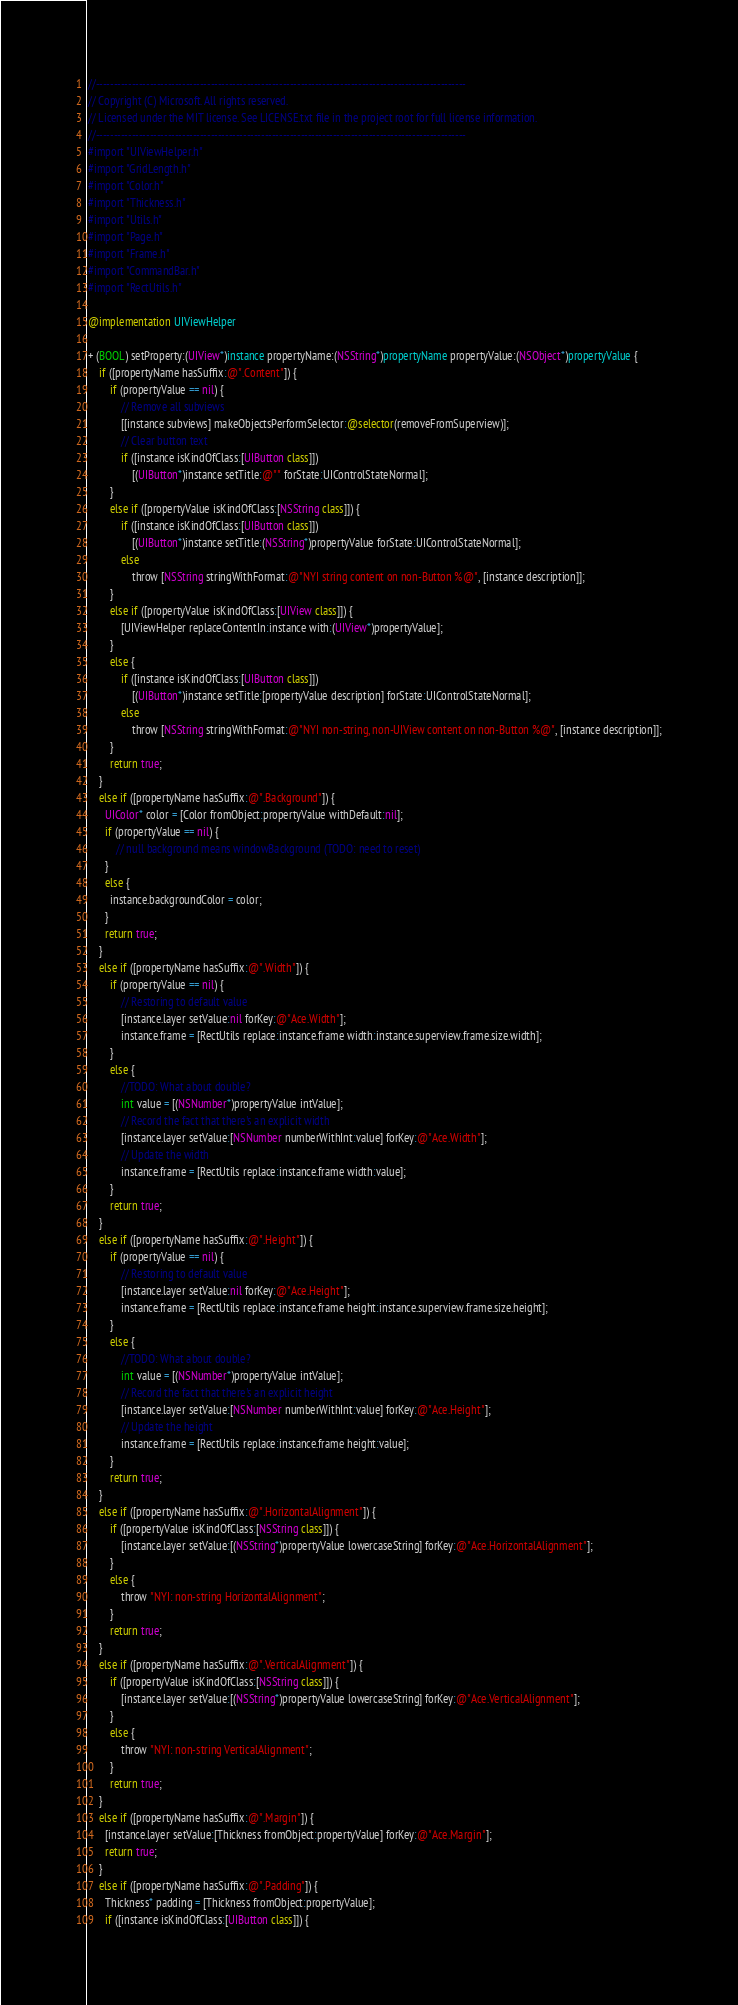Convert code to text. <code><loc_0><loc_0><loc_500><loc_500><_ObjectiveC_>//-------------------------------------------------------------------------------------------------------
// Copyright (C) Microsoft. All rights reserved.
// Licensed under the MIT license. See LICENSE.txt file in the project root for full license information.
//-------------------------------------------------------------------------------------------------------
#import "UIViewHelper.h"
#import "GridLength.h"
#import "Color.h"
#import "Thickness.h"
#import "Utils.h"
#import "Page.h"
#import "Frame.h"
#import "CommandBar.h"
#import "RectUtils.h"

@implementation UIViewHelper

+ (BOOL) setProperty:(UIView*)instance propertyName:(NSString*)propertyName propertyValue:(NSObject*)propertyValue {
    if ([propertyName hasSuffix:@".Content"]) {
        if (propertyValue == nil) {
            // Remove all subviews
            [[instance subviews] makeObjectsPerformSelector:@selector(removeFromSuperview)];
            // Clear button text
            if ([instance isKindOfClass:[UIButton class]])
                [(UIButton*)instance setTitle:@"" forState:UIControlStateNormal];
        }
        else if ([propertyValue isKindOfClass:[NSString class]]) {
            if ([instance isKindOfClass:[UIButton class]])
                [(UIButton*)instance setTitle:(NSString*)propertyValue forState:UIControlStateNormal];
            else
                throw [NSString stringWithFormat:@"NYI string content on non-Button %@", [instance description]];
        }
        else if ([propertyValue isKindOfClass:[UIView class]]) {
            [UIViewHelper replaceContentIn:instance with:(UIView*)propertyValue];
        }
        else {
            if ([instance isKindOfClass:[UIButton class]])
                [(UIButton*)instance setTitle:[propertyValue description] forState:UIControlStateNormal];
            else
                throw [NSString stringWithFormat:@"NYI non-string, non-UIView content on non-Button %@", [instance description]];
        }
        return true;
    }
    else if ([propertyName hasSuffix:@".Background"]) {
      UIColor* color = [Color fromObject:propertyValue withDefault:nil];
      if (propertyValue == nil) {
          // null background means windowBackground (TODO: need to reset)
      }
      else {
        instance.backgroundColor = color;
      }
      return true;
    }
    else if ([propertyName hasSuffix:@".Width"]) {
        if (propertyValue == nil) {
            // Restoring to default value
            [instance.layer setValue:nil forKey:@"Ace.Width"];
            instance.frame = [RectUtils replace:instance.frame width:instance.superview.frame.size.width];
        }
        else {
            //TODO: What about double?
            int value = [(NSNumber*)propertyValue intValue];
            // Record the fact that there's an explicit width
            [instance.layer setValue:[NSNumber numberWithInt:value] forKey:@"Ace.Width"];
            // Update the width
            instance.frame = [RectUtils replace:instance.frame width:value];
        }
        return true;
    }
    else if ([propertyName hasSuffix:@".Height"]) {
        if (propertyValue == nil) {
            // Restoring to default value
            [instance.layer setValue:nil forKey:@"Ace.Height"];
            instance.frame = [RectUtils replace:instance.frame height:instance.superview.frame.size.height];
        }
        else {
            //TODO: What about double?
            int value = [(NSNumber*)propertyValue intValue];
            // Record the fact that there's an explicit height
            [instance.layer setValue:[NSNumber numberWithInt:value] forKey:@"Ace.Height"];
            // Update the height
            instance.frame = [RectUtils replace:instance.frame height:value];
        }
        return true;
    }
    else if ([propertyName hasSuffix:@".HorizontalAlignment"]) {
        if ([propertyValue isKindOfClass:[NSString class]]) {
            [instance.layer setValue:[(NSString*)propertyValue lowercaseString] forKey:@"Ace.HorizontalAlignment"];
        }
        else {
            throw "NYI: non-string HorizontalAlignment";
        }
        return true;
    }
    else if ([propertyName hasSuffix:@".VerticalAlignment"]) {
        if ([propertyValue isKindOfClass:[NSString class]]) {
            [instance.layer setValue:[(NSString*)propertyValue lowercaseString] forKey:@"Ace.VerticalAlignment"];
        }
        else {
            throw "NYI: non-string VerticalAlignment";
        }
        return true;
    }
    else if ([propertyName hasSuffix:@".Margin"]) {
      [instance.layer setValue:[Thickness fromObject:propertyValue] forKey:@"Ace.Margin"];
      return true;
    }
    else if ([propertyName hasSuffix:@".Padding"]) {
      Thickness* padding = [Thickness fromObject:propertyValue];
      if ([instance isKindOfClass:[UIButton class]]) {</code> 